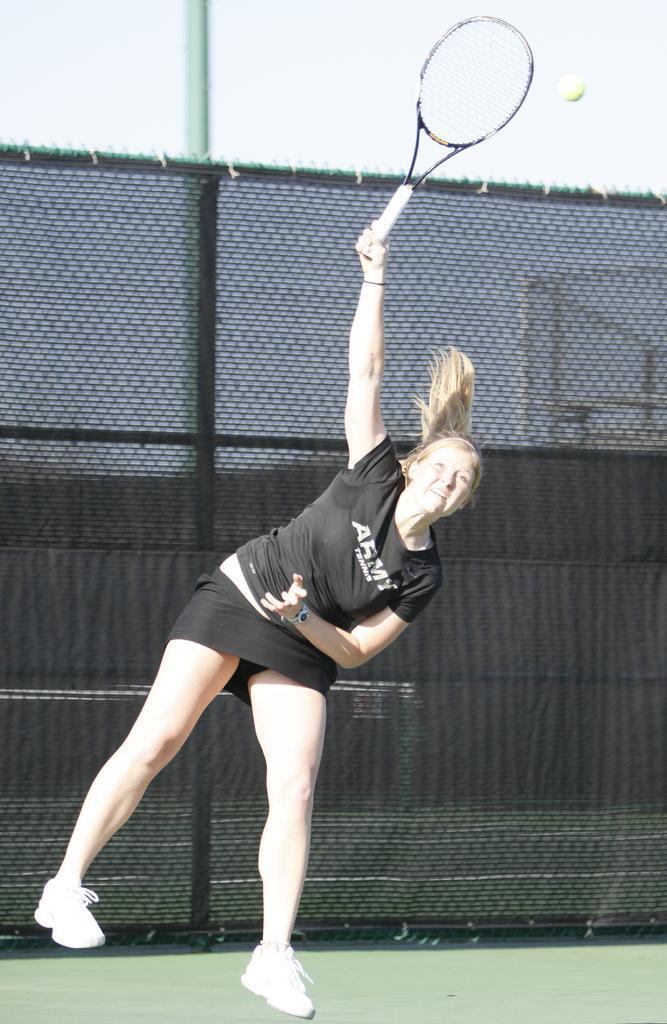Describe this image in one or two sentences. Here we can see a women who is playing a badminton. There is a mesh and this is ground. 